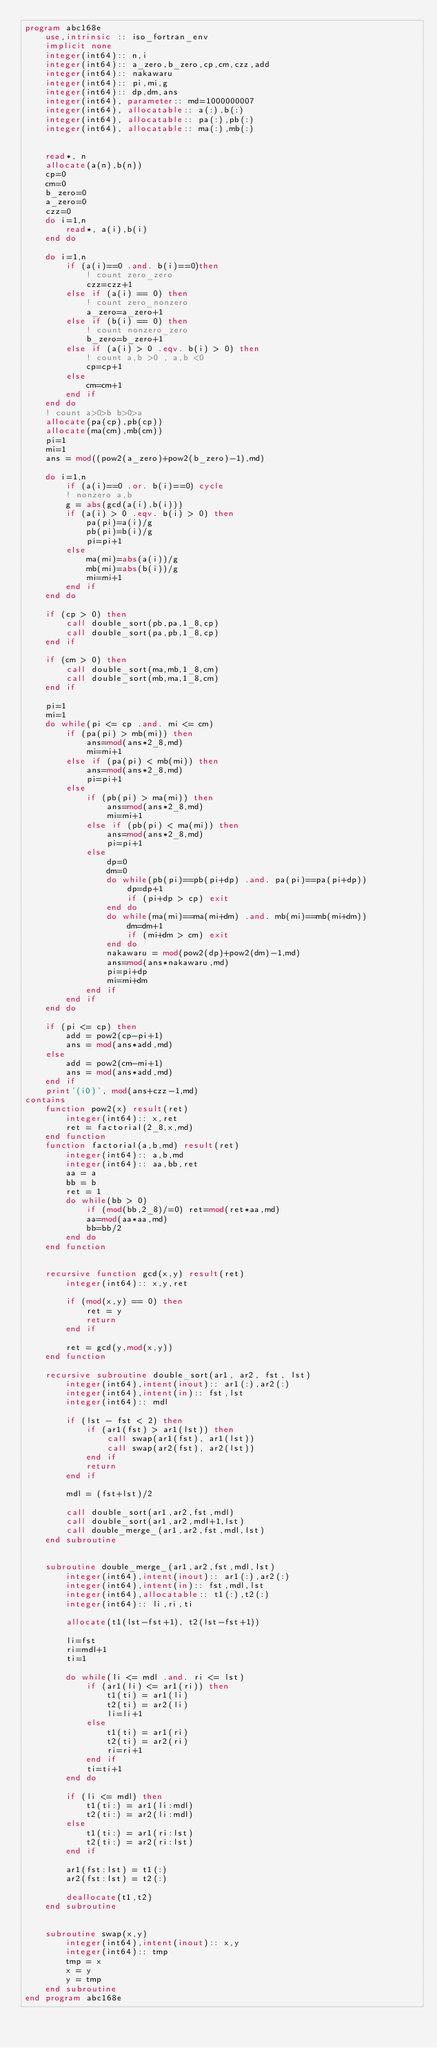Convert code to text. <code><loc_0><loc_0><loc_500><loc_500><_FORTRAN_>program abc168e
    use,intrinsic :: iso_fortran_env
    implicit none
    integer(int64):: n,i
    integer(int64):: a_zero,b_zero,cp,cm,czz,add
    integer(int64):: nakawaru
    integer(int64):: pi,mi,g
    integer(int64):: dp,dm,ans
    integer(int64), parameter:: md=1000000007
    integer(int64), allocatable:: a(:),b(:)
    integer(int64), allocatable:: pa(:),pb(:)
    integer(int64), allocatable:: ma(:),mb(:)


    read*, n
    allocate(a(n),b(n))
    cp=0
    cm=0
    b_zero=0
    a_zero=0
    czz=0
    do i=1,n
        read*, a(i),b(i)
    end do

    do i=1,n
        if (a(i)==0 .and. b(i)==0)then
            ! count zero_zero
            czz=czz+1
        else if (a(i) == 0) then
            ! count zero_nonzero
            a_zero=a_zero+1
        else if (b(i) == 0) then
            ! count nonzero_zero
            b_zero=b_zero+1
        else if (a(i) > 0 .eqv. b(i) > 0) then
            ! count a,b >0 , a,b <0
            cp=cp+1
        else
            cm=cm+1
        end if
    end do
    ! count a>0>b b>0>a
    allocate(pa(cp),pb(cp))
    allocate(ma(cm),mb(cm))
    pi=1
    mi=1
    ans = mod((pow2(a_zero)+pow2(b_zero)-1),md)
    
    do i=1,n
        if (a(i)==0 .or. b(i)==0) cycle
        ! nonzero a,b
        g = abs(gcd(a(i),b(i)))
        if (a(i) > 0 .eqv. b(i) > 0) then
            pa(pi)=a(i)/g
            pb(pi)=b(i)/g
            pi=pi+1
        else
            ma(mi)=abs(a(i))/g
            mb(mi)=abs(b(i))/g
            mi=mi+1
        end if
    end do

    if (cp > 0) then
        call double_sort(pb,pa,1_8,cp)
        call double_sort(pa,pb,1_8,cp)
    end if

    if (cm > 0) then
        call double_sort(ma,mb,1_8,cm)
        call double_sort(mb,ma,1_8,cm)
    end if

    pi=1
    mi=1
    do while(pi <= cp .and. mi <= cm)
        if (pa(pi) > mb(mi)) then
            ans=mod(ans*2_8,md) 
            mi=mi+1
        else if (pa(pi) < mb(mi)) then
            ans=mod(ans*2_8,md)
            pi=pi+1
        else
            if (pb(pi) > ma(mi)) then
                ans=mod(ans*2_8,md)
                mi=mi+1
            else if (pb(pi) < ma(mi)) then
                ans=mod(ans*2_8,md)
                pi=pi+1
            else
                dp=0
                dm=0
                do while(pb(pi)==pb(pi+dp) .and. pa(pi)==pa(pi+dp))
                    dp=dp+1
                    if (pi+dp > cp) exit
                end do
                do while(ma(mi)==ma(mi+dm) .and. mb(mi)==mb(mi+dm))
                    dm=dm+1
                    if (mi+dm > cm) exit
                end do
                nakawaru = mod(pow2(dp)+pow2(dm)-1,md)
                ans=mod(ans*nakawaru,md)
                pi=pi+dp
                mi=mi+dm
            end if
        end if
    end do

    if (pi <= cp) then
        add = pow2(cp-pi+1)
        ans = mod(ans*add,md)
    else
        add = pow2(cm-mi+1)
        ans = mod(ans*add,md)
    end if
    print'(i0)', mod(ans+czz-1,md)
contains
    function pow2(x) result(ret)
        integer(int64):: x,ret
        ret = factorial(2_8,x,md)
    end function
    function factorial(a,b,md) result(ret)
        integer(int64):: a,b,md
        integer(int64):: aa,bb,ret
        aa = a
        bb = b
        ret = 1
        do while(bb > 0)
            if (mod(bb,2_8)/=0) ret=mod(ret*aa,md)
            aa=mod(aa*aa,md)
            bb=bb/2
        end do
    end function


    recursive function gcd(x,y) result(ret)
        integer(int64):: x,y,ret

        if (mod(x,y) == 0) then
            ret = y
            return
        end if

        ret = gcd(y,mod(x,y))
    end function

    recursive subroutine double_sort(ar1, ar2, fst, lst)
        integer(int64),intent(inout):: ar1(:),ar2(:)
        integer(int64),intent(in):: fst,lst
        integer(int64):: mdl

        if (lst - fst < 2) then
            if (ar1(fst) > ar1(lst)) then
                call swap(ar1(fst), ar1(lst))
                call swap(ar2(fst), ar2(lst))
            end if
            return
        end if

        mdl = (fst+lst)/2

        call double_sort(ar1,ar2,fst,mdl)
        call double_sort(ar1,ar2,mdl+1,lst)
        call double_merge_(ar1,ar2,fst,mdl,lst)
    end subroutine


    subroutine double_merge_(ar1,ar2,fst,mdl,lst)
        integer(int64),intent(inout):: ar1(:),ar2(:)
        integer(int64),intent(in):: fst,mdl,lst
        integer(int64),allocatable:: t1(:),t2(:)
        integer(int64):: li,ri,ti

        allocate(t1(lst-fst+1), t2(lst-fst+1))

        li=fst
        ri=mdl+1
        ti=1

        do while(li <= mdl .and. ri <= lst)
            if (ar1(li) <= ar1(ri)) then
                t1(ti) = ar1(li) 
                t2(ti) = ar2(li)
                li=li+1
            else
                t1(ti) = ar1(ri)
                t2(ti) = ar2(ri)
                ri=ri+1
            end if
            ti=ti+1
        end do

        if (li <= mdl) then
            t1(ti:) = ar1(li:mdl)
            t2(ti:) = ar2(li:mdl)
        else
            t1(ti:) = ar1(ri:lst)
            t2(ti:) = ar2(ri:lst)
        end if

        ar1(fst:lst) = t1(:)
        ar2(fst:lst) = t2(:)

        deallocate(t1,t2)
    end subroutine

    
    subroutine swap(x,y)
        integer(int64),intent(inout):: x,y
        integer(int64):: tmp
        tmp = x
        x = y
        y = tmp
    end subroutine
end program abc168e</code> 